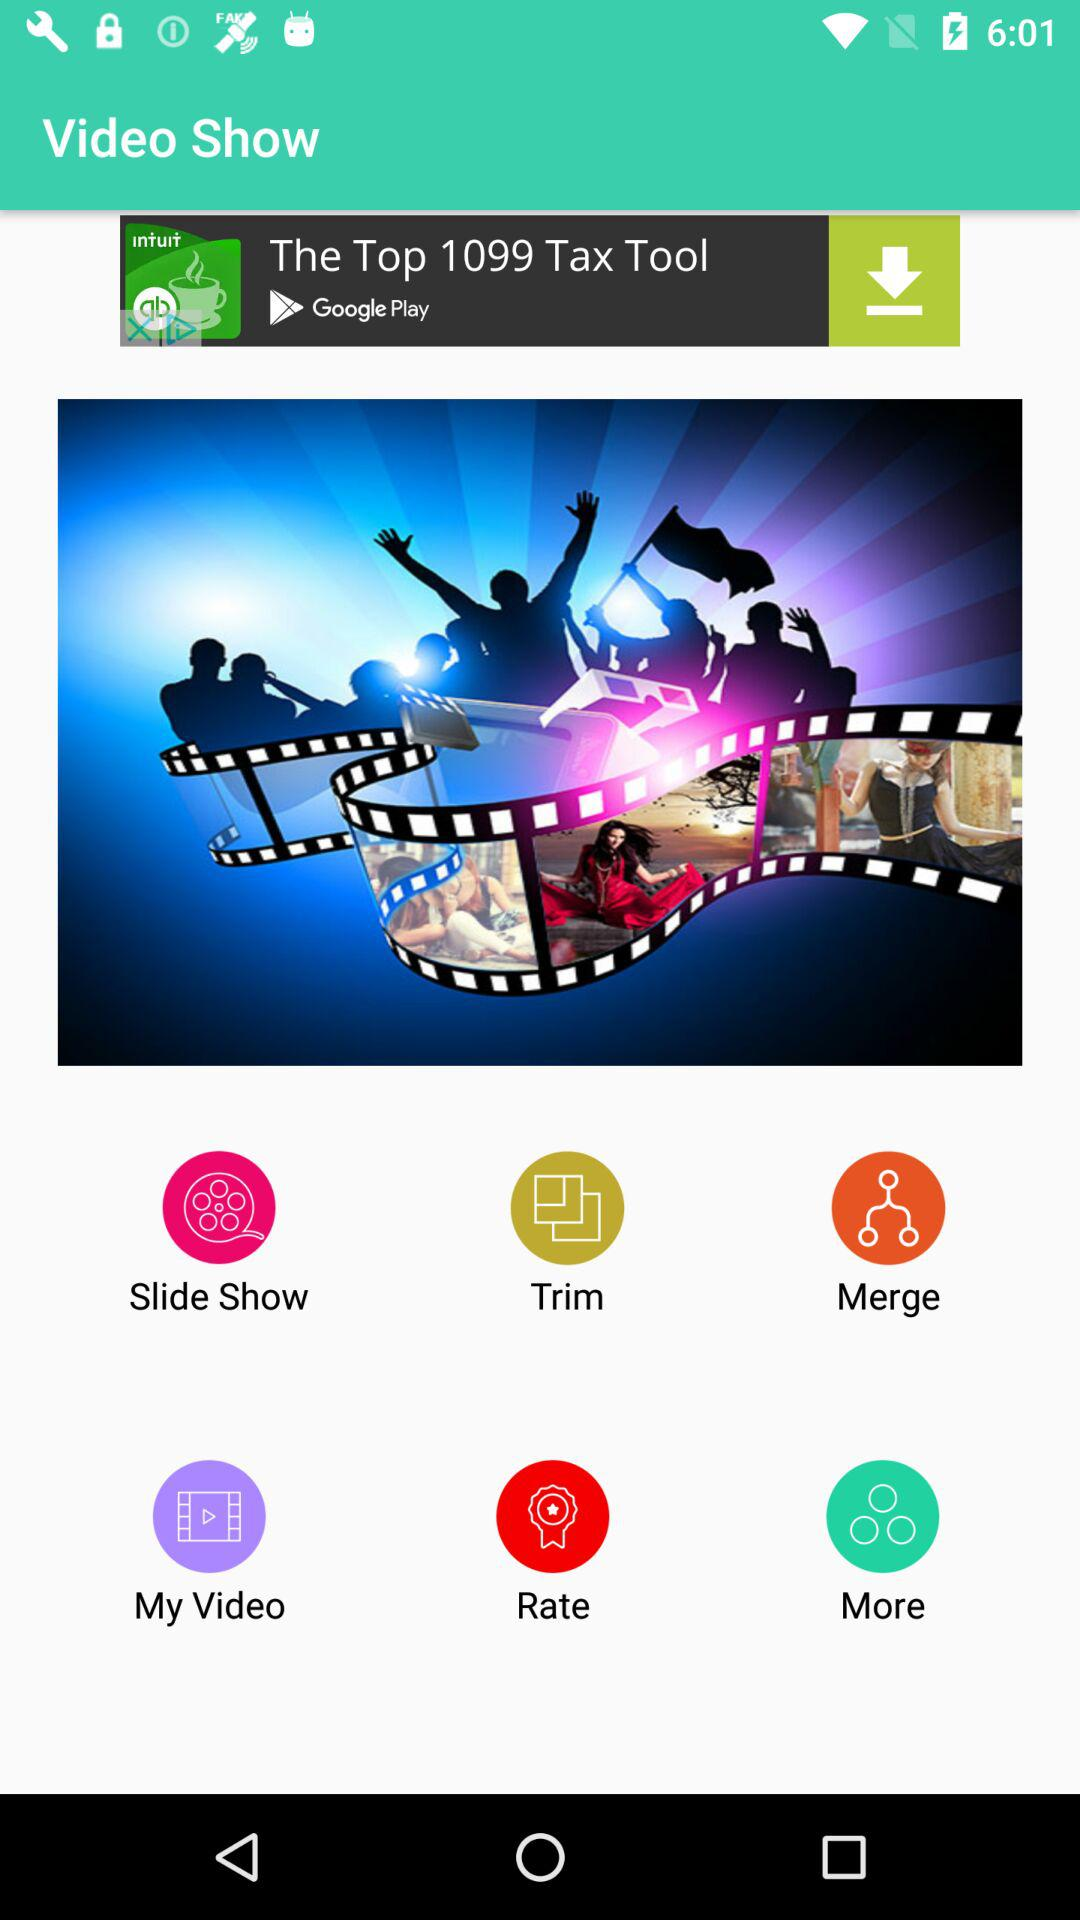What is the name of the application? The name of the application is "Video Show". 